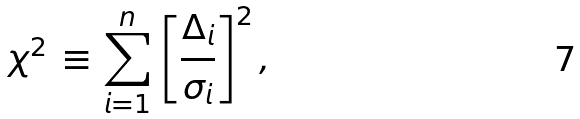<formula> <loc_0><loc_0><loc_500><loc_500>\chi ^ { 2 } \, \equiv \, \sum _ { i = 1 } ^ { n } \, \left [ \frac { \Delta _ { i } } { \sigma _ { i } } \right ] ^ { 2 } ,</formula> 